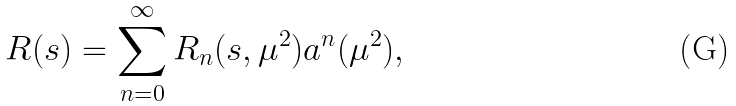Convert formula to latex. <formula><loc_0><loc_0><loc_500><loc_500>R ( s ) = \sum _ { n = 0 } ^ { \infty } R _ { n } ( s , \mu ^ { 2 } ) a ^ { n } ( \mu ^ { 2 } ) ,</formula> 